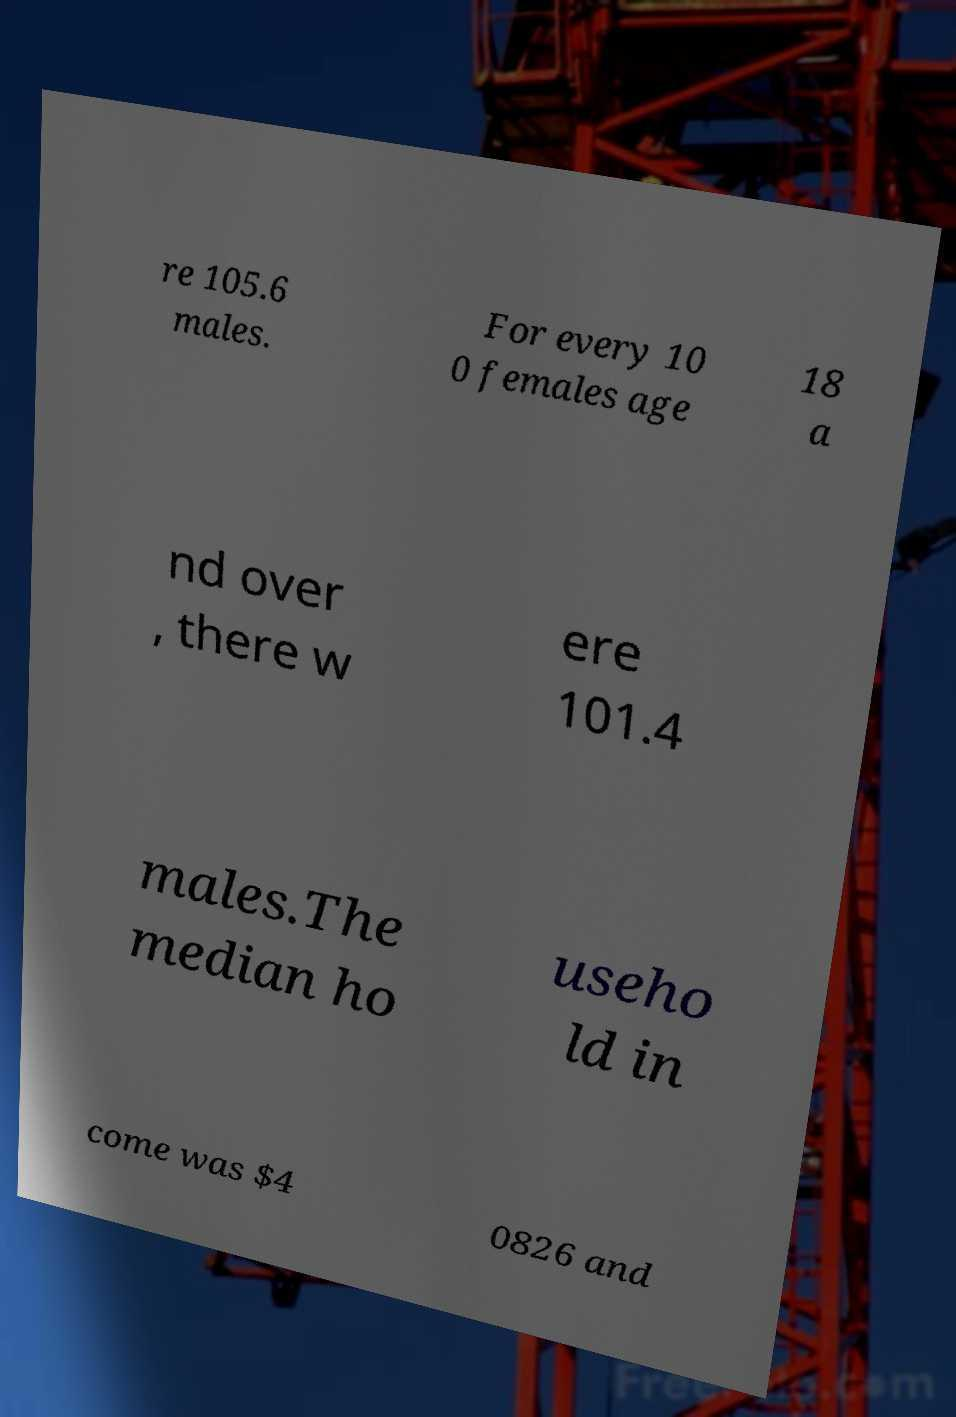Could you extract and type out the text from this image? re 105.6 males. For every 10 0 females age 18 a nd over , there w ere 101.4 males.The median ho useho ld in come was $4 0826 and 